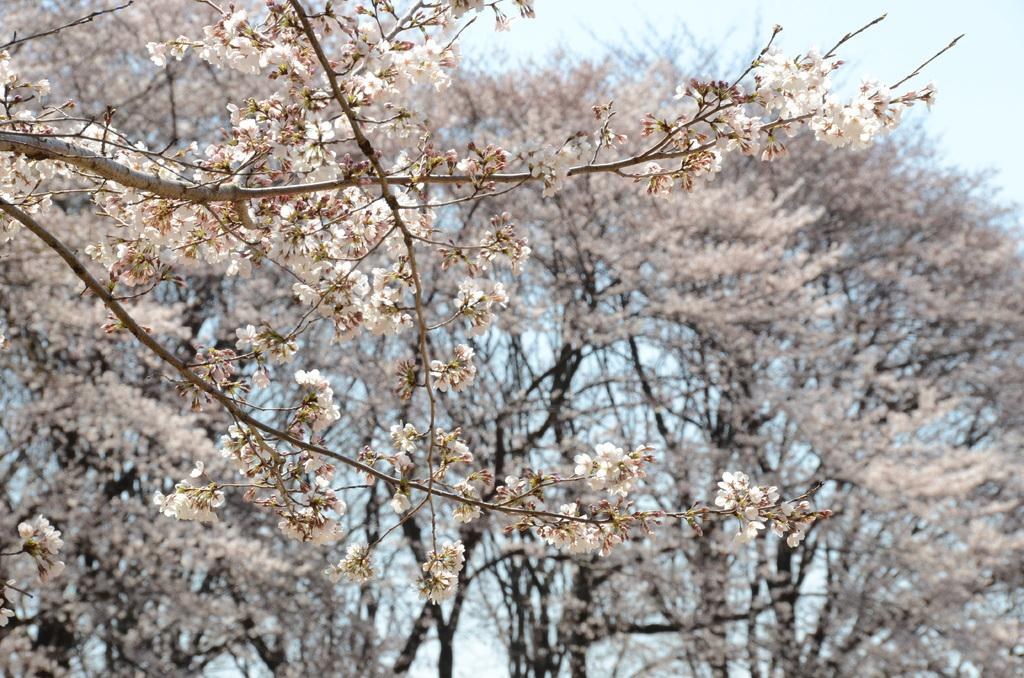What type of vegetation is present in the image? There are trees with flowers in the image. What is the condition of the branches on the trees? The branches on the trees are dried in the image. What is visible in the background of the image? The sky is visible in the image. How would you describe the sky in the image? The sky looks cloudy in the image. What type of meat is being prepared on the grill in the image? There is no grill or meat present in the image; it features trees with flowers and a cloudy sky. How many snails can be seen crawling on the branches of the trees in the image? There are no snails visible on the branches of the trees in the image. 